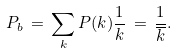<formula> <loc_0><loc_0><loc_500><loc_500>P _ { b } \, = \, \sum _ { k } P ( k ) \frac { 1 } { k } \, = \, \frac { 1 } { \overline { k } } .</formula> 